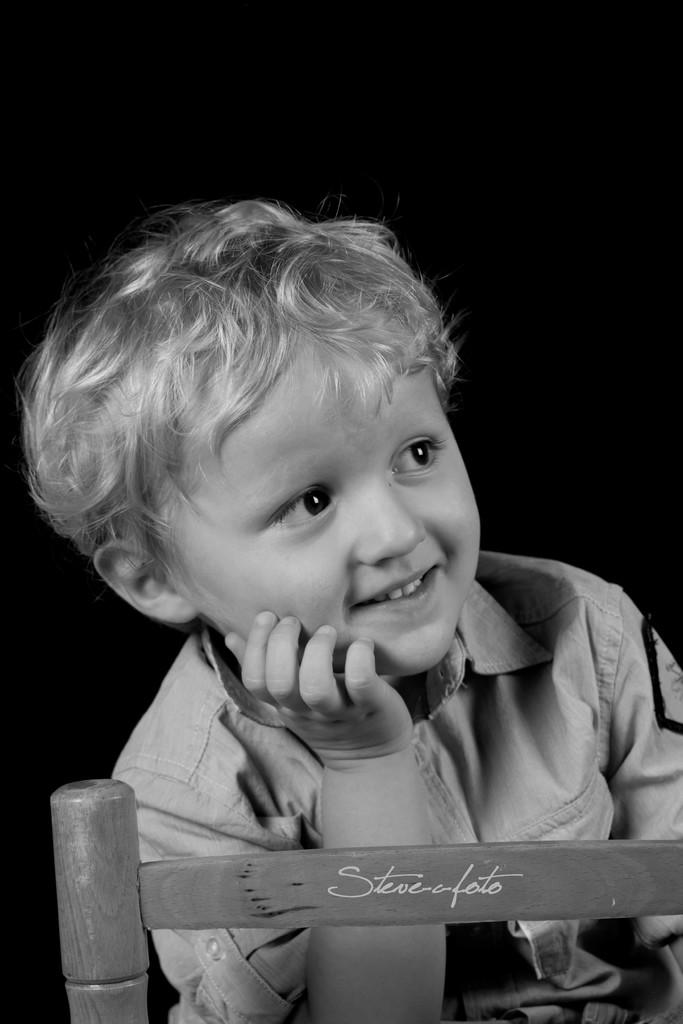What is the color scheme of the image? The image is black and white. Who is present in the image? There is a kid in the image. What is the kid's expression? The kid is smiling. What is the wooden object with text at the bottom of the image? It is not clear from the facts what the wooden object with text is, but it is present in the image. How would you describe the background of the image? The background of the image is dark. How much wealth does the kid possess in the image? There is no information about the kid's wealth in the image. What type of hammer is being used by the kid in the image? There is no hammer present in the image. 